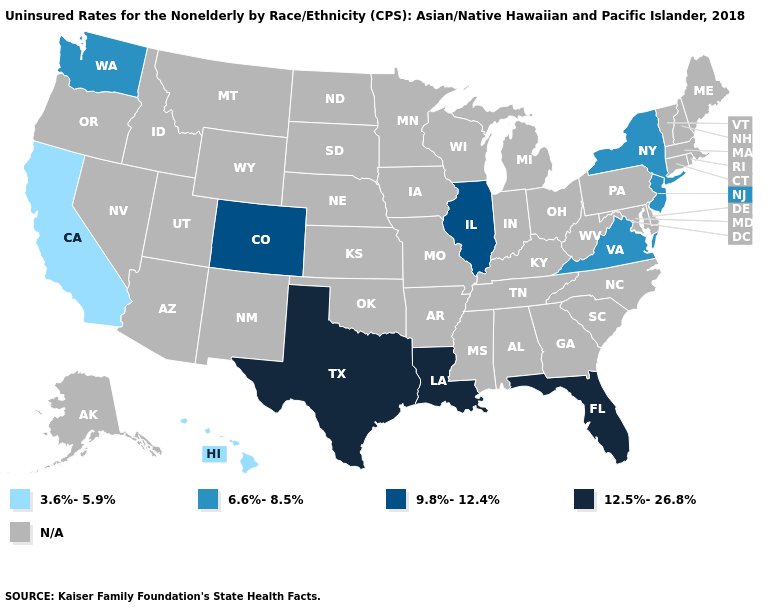Does Florida have the highest value in the USA?
Be succinct. Yes. What is the value of Minnesota?
Write a very short answer. N/A. What is the value of North Dakota?
Quick response, please. N/A. Name the states that have a value in the range 12.5%-26.8%?
Quick response, please. Florida, Louisiana, Texas. Is the legend a continuous bar?
Short answer required. No. Does the first symbol in the legend represent the smallest category?
Quick response, please. Yes. What is the value of Oklahoma?
Be succinct. N/A. Name the states that have a value in the range 12.5%-26.8%?
Answer briefly. Florida, Louisiana, Texas. Name the states that have a value in the range N/A?
Concise answer only. Alabama, Alaska, Arizona, Arkansas, Connecticut, Delaware, Georgia, Idaho, Indiana, Iowa, Kansas, Kentucky, Maine, Maryland, Massachusetts, Michigan, Minnesota, Mississippi, Missouri, Montana, Nebraska, Nevada, New Hampshire, New Mexico, North Carolina, North Dakota, Ohio, Oklahoma, Oregon, Pennsylvania, Rhode Island, South Carolina, South Dakota, Tennessee, Utah, Vermont, West Virginia, Wisconsin, Wyoming. What is the lowest value in the West?
Answer briefly. 3.6%-5.9%. Does Illinois have the highest value in the USA?
Quick response, please. No. Name the states that have a value in the range 9.8%-12.4%?
Quick response, please. Colorado, Illinois. Which states hav the highest value in the West?
Write a very short answer. Colorado. 